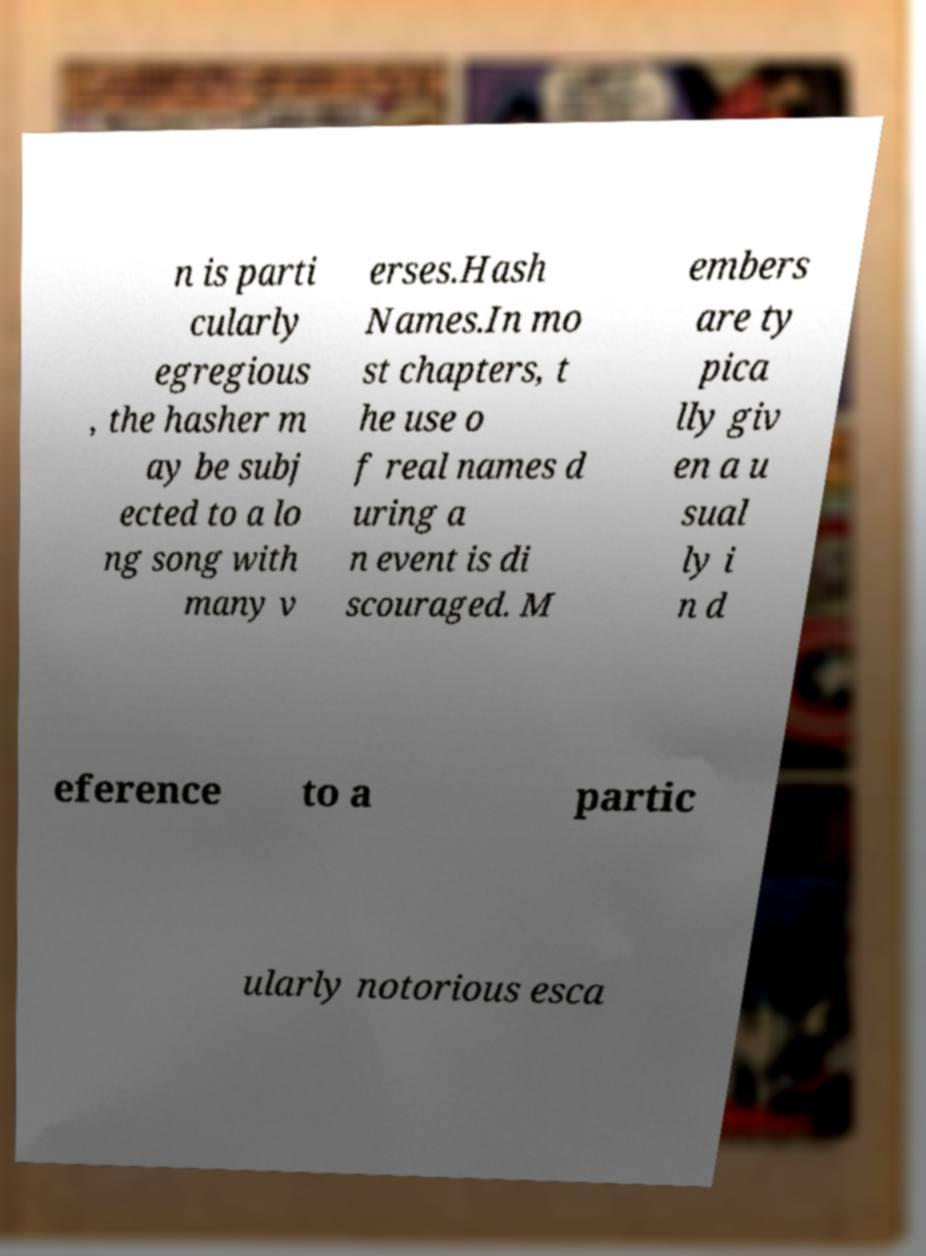Can you accurately transcribe the text from the provided image for me? n is parti cularly egregious , the hasher m ay be subj ected to a lo ng song with many v erses.Hash Names.In mo st chapters, t he use o f real names d uring a n event is di scouraged. M embers are ty pica lly giv en a u sual ly i n d eference to a partic ularly notorious esca 